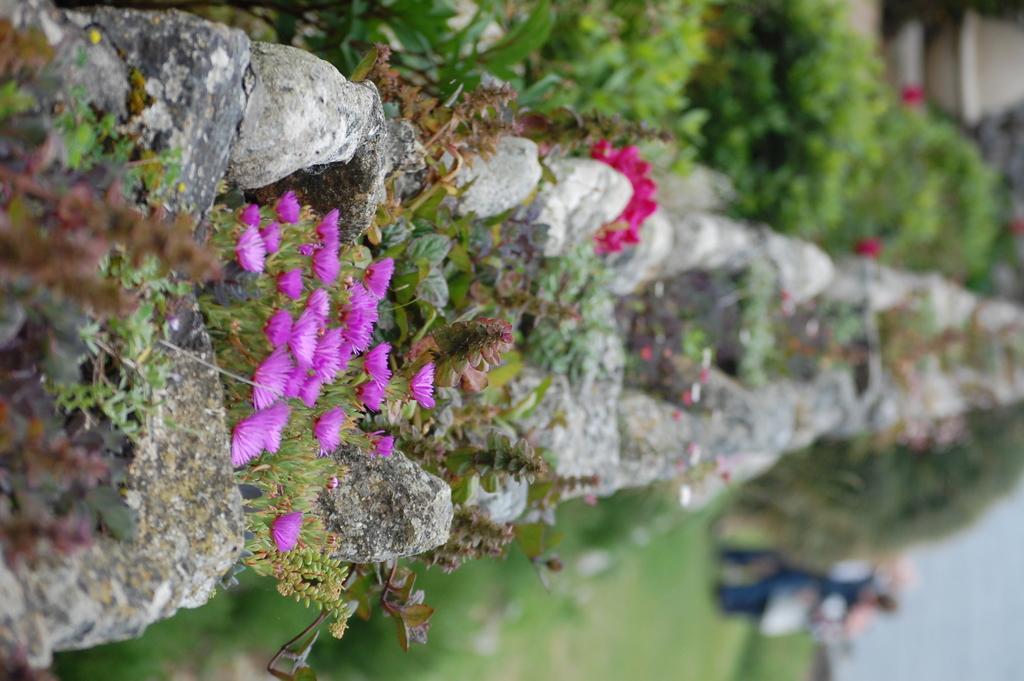Please provide a concise description of this image. In this image we can see a wall. On the wall we can see plants and flowers. Beside the wall we can see the plants and the grass. On the right side the image is blurred. 